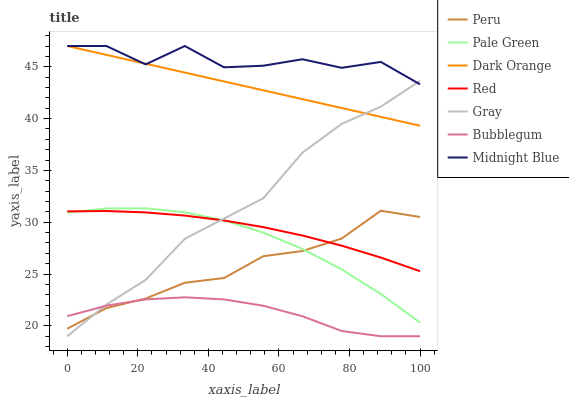Does Bubblegum have the minimum area under the curve?
Answer yes or no. Yes. Does Midnight Blue have the maximum area under the curve?
Answer yes or no. Yes. Does Gray have the minimum area under the curve?
Answer yes or no. No. Does Gray have the maximum area under the curve?
Answer yes or no. No. Is Dark Orange the smoothest?
Answer yes or no. Yes. Is Midnight Blue the roughest?
Answer yes or no. Yes. Is Gray the smoothest?
Answer yes or no. No. Is Gray the roughest?
Answer yes or no. No. Does Gray have the lowest value?
Answer yes or no. Yes. Does Midnight Blue have the lowest value?
Answer yes or no. No. Does Midnight Blue have the highest value?
Answer yes or no. Yes. Does Gray have the highest value?
Answer yes or no. No. Is Red less than Dark Orange?
Answer yes or no. Yes. Is Midnight Blue greater than Bubblegum?
Answer yes or no. Yes. Does Peru intersect Pale Green?
Answer yes or no. Yes. Is Peru less than Pale Green?
Answer yes or no. No. Is Peru greater than Pale Green?
Answer yes or no. No. Does Red intersect Dark Orange?
Answer yes or no. No. 